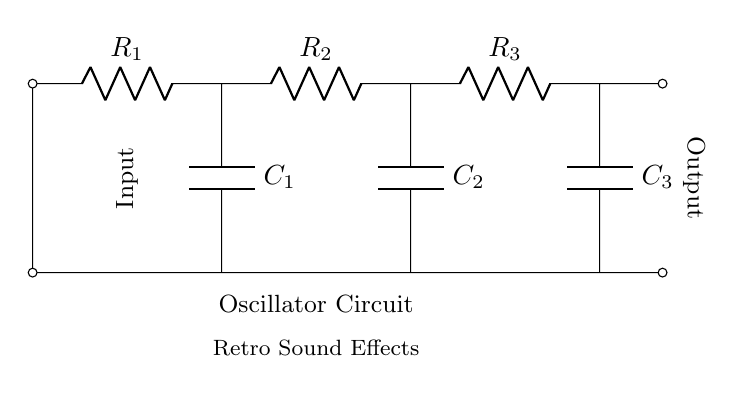What components are present in the circuit? The circuit contains three resistors (R1, R2, R3) and three capacitors (C1, C2, C3). Each component is labeled on the circuit diagram.
Answer: Resistors and capacitors What is the output of the oscillator circuit? The output is located at the right end of the circuit, designated as "Output." It conveys the sound effects generated by the oscillations.
Answer: Sound effects How many resistors are connected in this circuit? There are three resistors labeled R1, R2, and R3 in the circuit diagram. The count of resistors is straightforward from the labels.
Answer: Three How do the capacitors affect the sound produced? Capacitors store and release charge, affecting the timing of oscillations, which influences the frequency of the sound waves generated. A deeper understanding of capacitance and frequency relationships provides clarity.
Answer: Influence frequency What is the role of the resistors in this circuit? Resistors control the current flow and charge rate of the capacitors, which affects the oscillation frequency. Understanding Ohm's Law and its impact on RC time constants aids comprehension here.
Answer: Control current Which resistor is closest to the output? Resistor R3 is the closest to the output, as it is positioned on the right side of the circuit near the output connection.
Answer: R3 What type of circuit is this primarily classified as? This circuit is classified as an oscillator circuit, specifically a resistor-capacitor oscillator due to the combination of resistors and capacitors used for generating oscillations. Understanding the fundamental operation of oscillators provides insight into its classification.
Answer: Oscillator circuit 